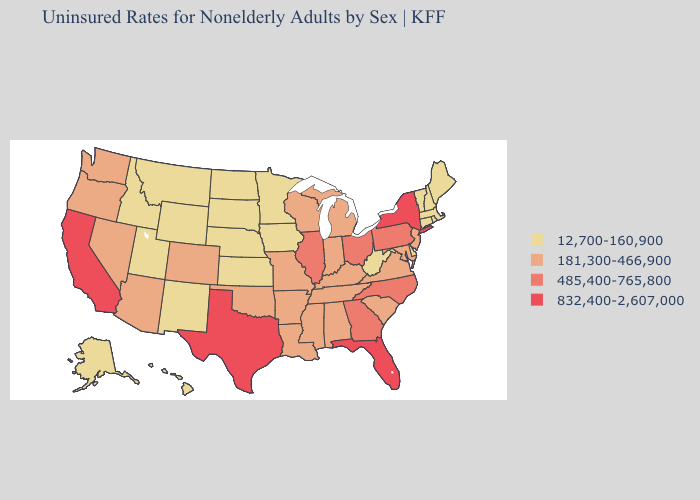What is the highest value in states that border Washington?
Be succinct. 181,300-466,900. Does Kentucky have the highest value in the South?
Keep it brief. No. What is the highest value in states that border Massachusetts?
Give a very brief answer. 832,400-2,607,000. Does Maine have the lowest value in the USA?
Concise answer only. Yes. What is the value of Oregon?
Be succinct. 181,300-466,900. Which states hav the highest value in the MidWest?
Give a very brief answer. Illinois, Ohio. Name the states that have a value in the range 181,300-466,900?
Concise answer only. Alabama, Arizona, Arkansas, Colorado, Indiana, Kentucky, Louisiana, Maryland, Michigan, Mississippi, Missouri, Nevada, New Jersey, Oklahoma, Oregon, South Carolina, Tennessee, Virginia, Washington, Wisconsin. What is the value of Virginia?
Short answer required. 181,300-466,900. How many symbols are there in the legend?
Short answer required. 4. Does Florida have the highest value in the USA?
Keep it brief. Yes. Among the states that border Oklahoma , which have the highest value?
Keep it brief. Texas. What is the value of South Carolina?
Short answer required. 181,300-466,900. Does the map have missing data?
Answer briefly. No. Does the first symbol in the legend represent the smallest category?
Short answer required. Yes. Does Florida have the highest value in the USA?
Be succinct. Yes. 